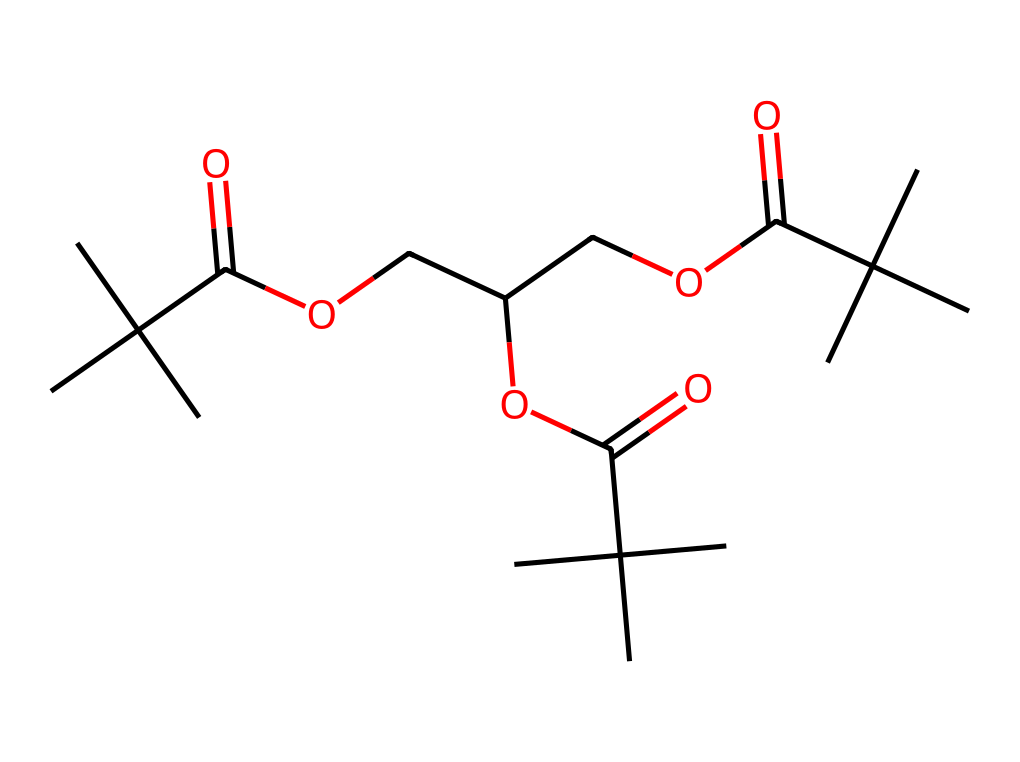what is the molecular formula of this compound? To determine the molecular formula, count the number of each type of atom present in the structure represented by the SMILES. The SMILES indicates the presence of carbon (C), hydrogen (H), and oxygen (O) atoms. By counting, we find there are 24 carbon atoms, 46 hydrogen atoms, and 6 oxygen atoms. Thus, the molecular formula is C24H46O6.
Answer: C24H46O6 how many ester functional groups are present in this chemical structure? In the SMILES representation, look for the pattern "C(=O)O," which indicates an ester group. By examining the structure, we identify three occurrences of this pattern, confirming three ester functional groups in the compound.
Answer: 3 what type of polymerization might be involved in the production of this dental impression material? Given the structure includes multiple repeating units that are connected through ester linkages, this suggests that the polymerization process could involve step-growth polymerization, which is common in polymer chemistry, especially for polyesters.
Answer: step-growth what is the primary role of this compound in dental applications? This compound, being a polymer structure in dental impression materials, primarily serves to capture detailed impressions of teeth and gums due to its ability to achieve accurate replication and stability under use conditions.
Answer: accurate replication which part of the structure contributes to flexibility in the polymer? The presence of the ester linkages and the branched alkyl groups in the structure allows for increased molecular mobility, contributing to the flexibility of the polymer. The branched groups prevent tight packing, enhancing flexibility.
Answer: branched alkyl groups how many chiral centers are present in this molecule? A chiral center is typically defined by a carbon atom attached to four different substituents. By counting within the SMILES structure, we identify four carbon atoms that fit this criterion, indicating the presence of four chiral centers in the molecule.
Answer: 4 